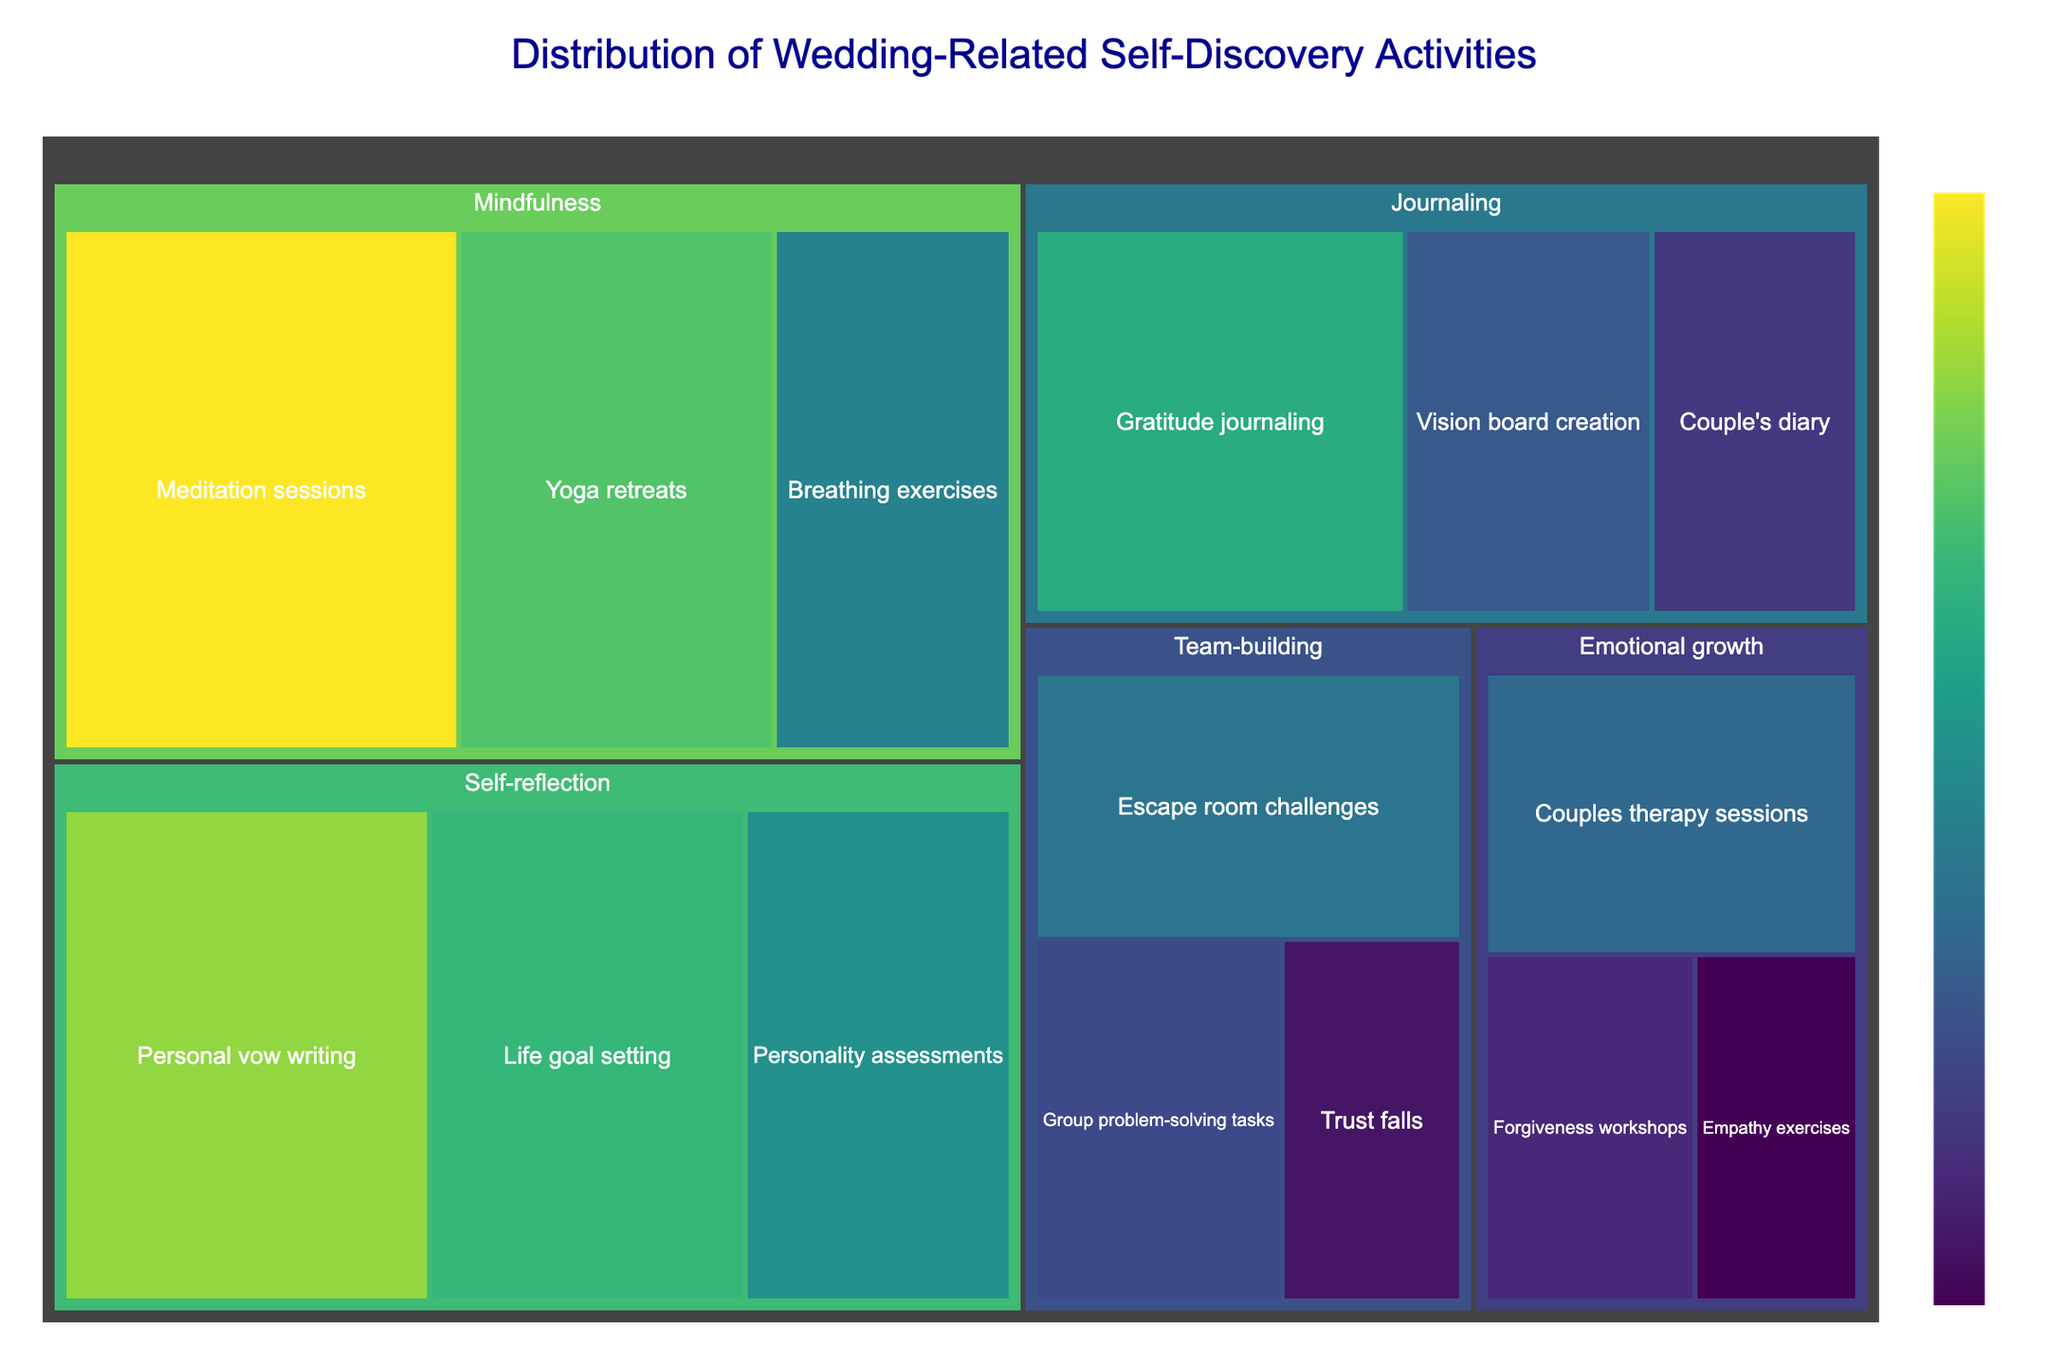what is the title of the figure? The title is typically displayed at the top of the treemap and provides a summary of the data being visualized. In this case, the title explicitly states the subject of the treemap.
Answer: Distribution of Wedding-Related Self-Discovery Activities which category has the largest total value? By checking the aggregated value of each category, we can see which one has the largest total value. Summing up the values for each category reveals that "Mindfulness" has the highest total value.
Answer: Mindfulness how many subcategories are there under the journaling category? By analyzing the figure, you can see the breakdown of each category into its subcategories. Counting the subcategories under "Journaling" gives us three: Gratitude journaling, Vision board creation, and Couple's diary.
Answer: 3 what is the combined value of the activities related to self-reflection? To find the combined value, sum the individual values of each subcategory within the "Self-reflection" category. The sum is 22 (Personal vow writing) + 19 (Life goal setting) + 16 (Personality assessments).
Answer: 57 which subcategory has the lowest value in emotional growth? By comparing the subcategories within "Emotional growth", the one with the lowest value can be identified as Empathy exercises with a value of 7.
Answer: Empathy exercises which two categories have the closest total value? Sum the values of subcategories for each main category, then compare the totals to find the closest values. "Emotional growth" (29) and "Team-building" (33) are the closest.
Answer: Emotional growth and Team-building what is the difference in value between the highest and lowest subcategory in mindfulness? Identify the highest (Meditation sessions, 25) and lowest (Breathing exercises, 15) values in "Mindfulness", then subtract the lowest from the highest. 25 - 15 = 10.
Answer: 10 which category has the most diverse range of activity values? By examining the range by calculating the difference between the highest and lowest values for each category, "Mindfulness" has the most diverse range (25 - 15 = 10).
Answer: Mindfulness how does the value of couple's therapy sessions compare to trust falls? By directly comparing the values of these two subcategories, we find that Couple's therapy sessions (13) has a higher value than Trust falls (8).
Answer: Couple's therapy sessions is higher 